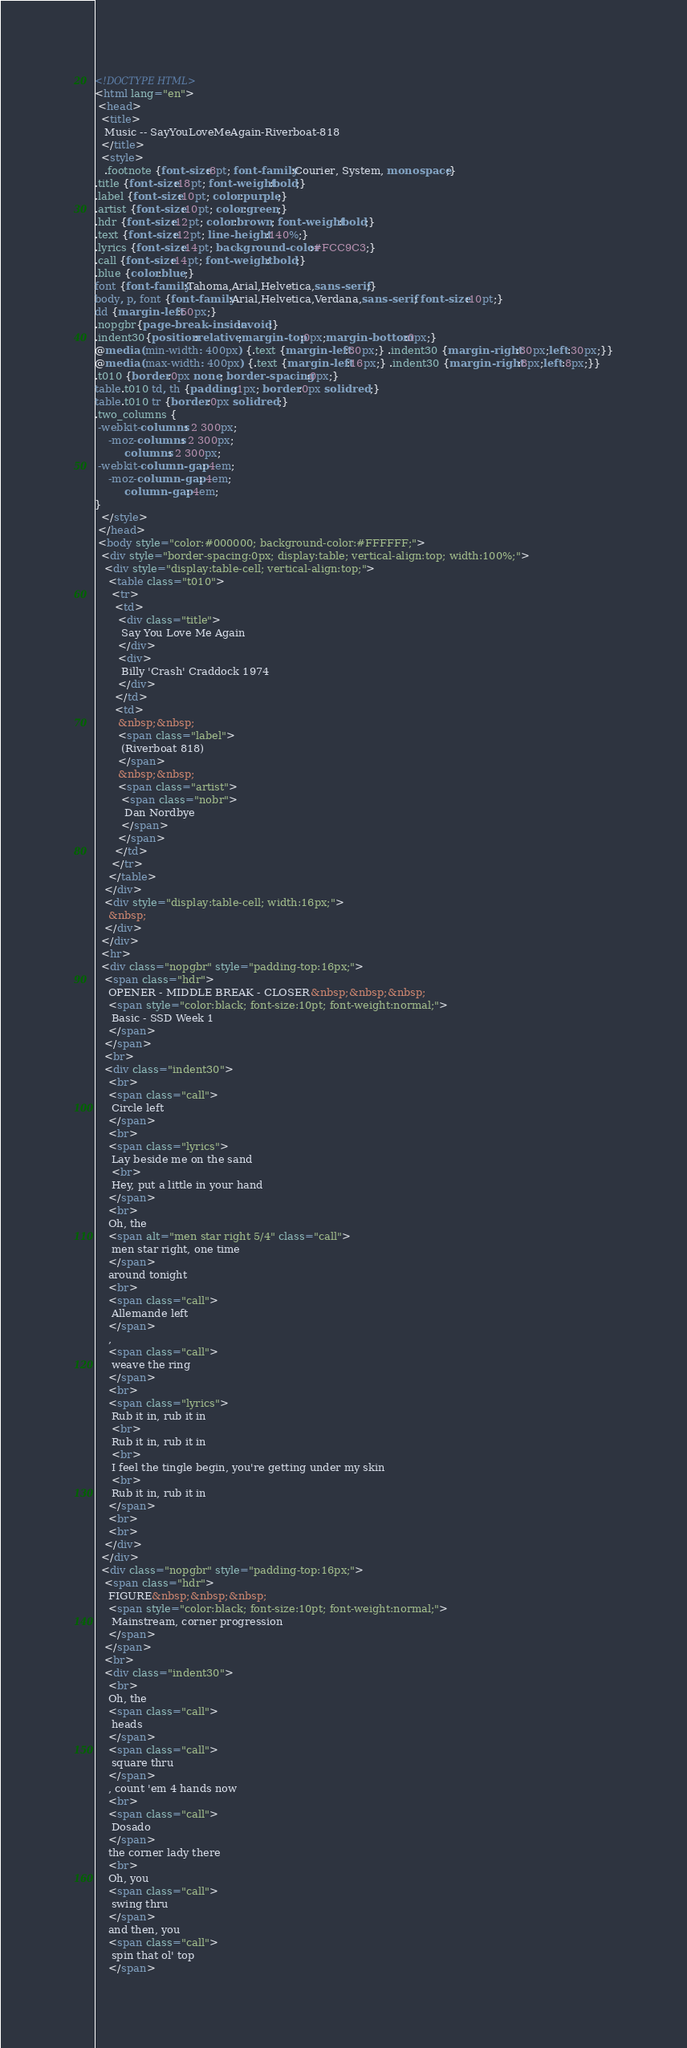Convert code to text. <code><loc_0><loc_0><loc_500><loc_500><_HTML_><!DOCTYPE HTML>
<html lang="en">
 <head>
  <title>
   Music -- SayYouLoveMeAgain-Riverboat-818
  </title>
  <style>
   .footnote {font-size:8pt; font-family:Courier, System, monospace;}
.title {font-size:18pt; font-weight:bold;}
.label {font-size:10pt; color:purple;}
.artist {font-size:10pt; color:green;}
.hdr {font-size:12pt; color:brown; font-weight:bold;}
.text {font-size:12pt; line-height:140%;}
.lyrics {font-size:14pt; background-color:#FCC9C3;}
.call {font-size:14pt; font-weight: bold;}
.blue {color:blue;}
font {font-family:Tahoma,Arial,Helvetica,sans-serif;}
body, p, font {font-family:Arial,Helvetica,Verdana,sans-serif; font-size:10pt;}
dd {margin-left:50px;}
.nopgbr{page-break-inside:avoid;}
.indent30{position:relative;margin-top:0px;margin-bottom:0px;}
@media (min-width: 400px) {.text {margin-left:30px;} .indent30 {margin-right:30px;left:30px;}}
@media (max-width: 400px) {.text {margin-left:16px;} .indent30 {margin-right:8px;left:8px;}}
.t010 {border:0px none; border-spacing:0px;}
table.t010 td, th {padding:1px; border:0px solid red;}
table.t010 tr {border:0px solid red;}
.two_columns {
 -webkit-columns: 2 300px;
    -moz-columns: 2 300px;
         columns: 2 300px;
 -webkit-column-gap: 4em;
    -moz-column-gap: 4em;
         column-gap: 4em;
}
  </style>
 </head>
 <body style="color:#000000; background-color:#FFFFFF;">
  <div style="border-spacing:0px; display:table; vertical-align:top; width:100%;">
   <div style="display:table-cell; vertical-align:top;">
    <table class="t010">
     <tr>
      <td>
       <div class="title">
        Say You Love Me Again
       </div>
       <div>
        Billy 'Crash' Craddock 1974
       </div>
      </td>
      <td>
       &nbsp;&nbsp;
       <span class="label">
        (Riverboat 818)
       </span>
       &nbsp;&nbsp;
       <span class="artist">
        <span class="nobr">
         Dan Nordbye
        </span>
       </span>
      </td>
     </tr>
    </table>
   </div>
   <div style="display:table-cell; width:16px;">
    &nbsp;
   </div>
  </div>
  <hr>
  <div class="nopgbr" style="padding-top:16px;">
   <span class="hdr">
    OPENER - MIDDLE BREAK - CLOSER&nbsp;&nbsp;&nbsp;
    <span style="color:black; font-size:10pt; font-weight:normal;">
     Basic - SSD Week 1
    </span>
   </span>
   <br>
   <div class="indent30">
    <br>
    <span class="call">
     Circle left
    </span>
    <br>
    <span class="lyrics">
     Lay beside me on the sand
     <br>
     Hey, put a little in your hand
    </span>
    <br>
    Oh, the
    <span alt="men star right 5/4" class="call">
     men star right, one time
    </span>
    around tonight
    <br>
    <span class="call">
     Allemande left
    </span>
    ,
    <span class="call">
     weave the ring
    </span>
    <br>
    <span class="lyrics">
     Rub it in, rub it in
     <br>
     Rub it in, rub it in
     <br>
     I feel the tingle begin, you're getting under my skin
     <br>
     Rub it in, rub it in
    </span>
    <br>
    <br>
   </div>
  </div>
  <div class="nopgbr" style="padding-top:16px;">
   <span class="hdr">
    FIGURE&nbsp;&nbsp;&nbsp;
    <span style="color:black; font-size:10pt; font-weight:normal;">
     Mainstream, corner progression
    </span>
   </span>
   <br>
   <div class="indent30">
    <br>
    Oh, the
    <span class="call">
     heads
    </span>
    <span class="call">
     square thru
    </span>
    , count 'em 4 hands now
    <br>
    <span class="call">
     Dosado
    </span>
    the corner lady there
    <br>
    Oh, you
    <span class="call">
     swing thru
    </span>
    and then, you
    <span class="call">
     spin that ol' top
    </span></code> 